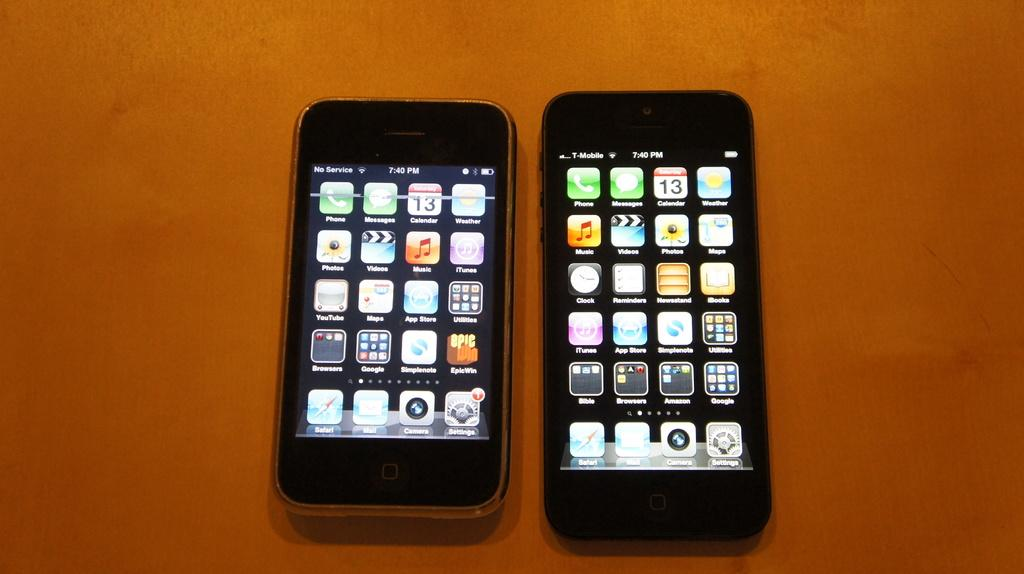How many mobile phones are visible in the image? There are two mobile phones in the image. Where are the mobile phones located? The mobile phones are on a table. What state are the mobile phones in? The screens of both mobile phones are open. What type of toy can be seen floating in the air above the mobile phones? There is no toy present in the image, and nothing is floating in the air above the mobile phones. 